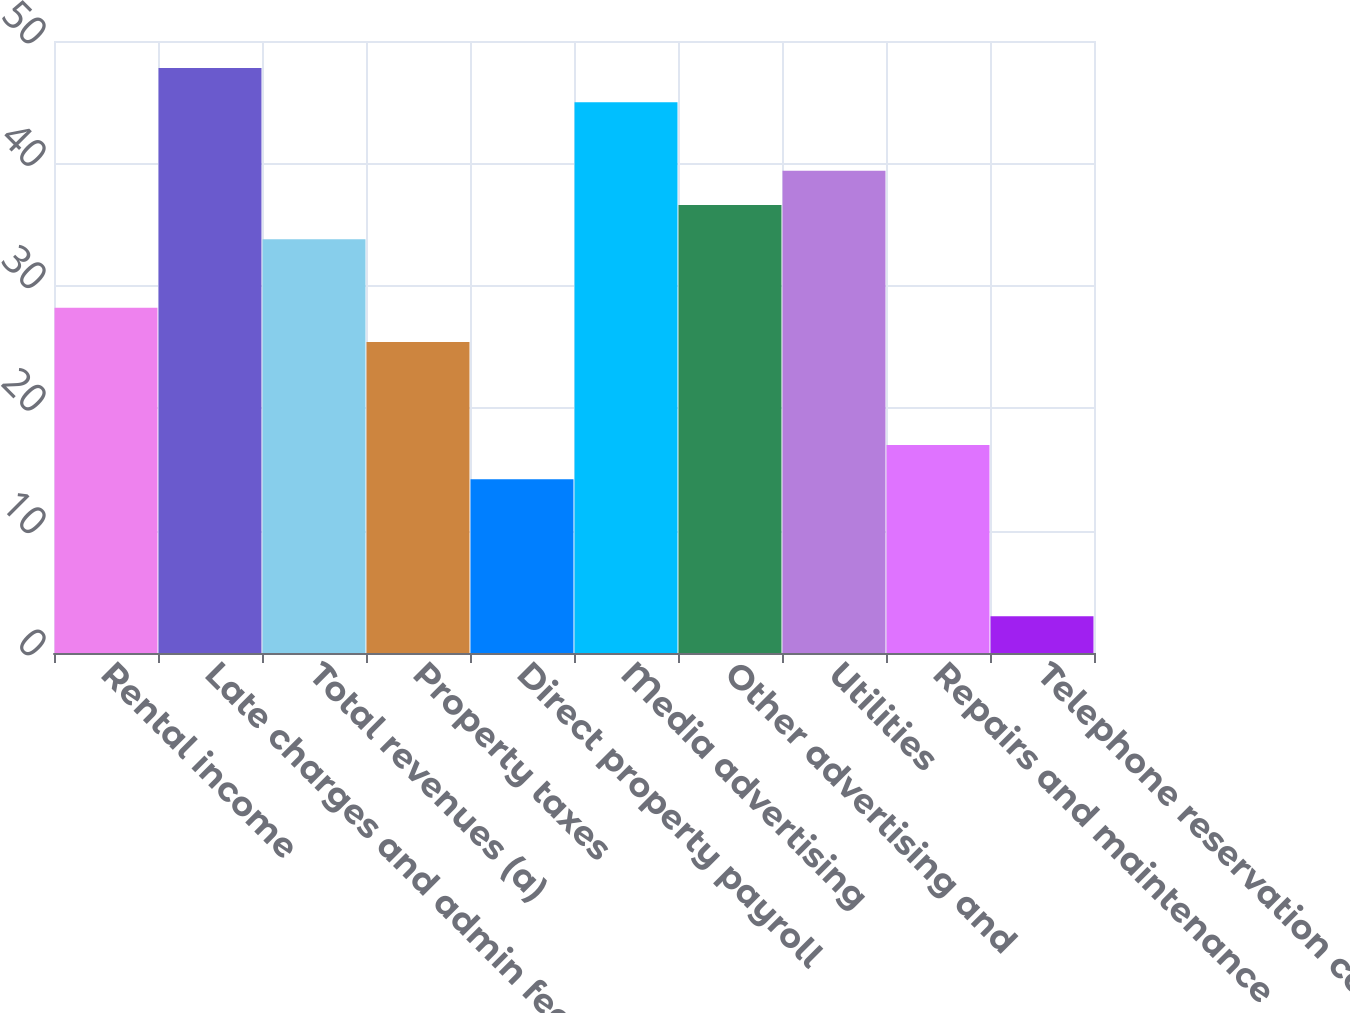Convert chart to OTSL. <chart><loc_0><loc_0><loc_500><loc_500><bar_chart><fcel>Rental income<fcel>Late charges and admin fees<fcel>Total revenues (a)<fcel>Property taxes<fcel>Direct property payroll<fcel>Media advertising<fcel>Other advertising and<fcel>Utilities<fcel>Repairs and maintenance<fcel>Telephone reservation center<nl><fcel>28.2<fcel>47.8<fcel>33.8<fcel>25.4<fcel>14.2<fcel>45<fcel>36.6<fcel>39.4<fcel>17<fcel>3<nl></chart> 